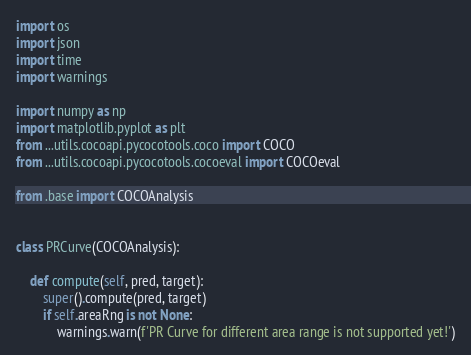Convert code to text. <code><loc_0><loc_0><loc_500><loc_500><_Python_>import os
import json
import time
import warnings

import numpy as np
import matplotlib.pyplot as plt
from ...utils.cocoapi.pycocotools.coco import COCO
from ...utils.cocoapi.pycocotools.cocoeval import COCOeval

from .base import COCOAnalysis


class PRCurve(COCOAnalysis):

    def compute(self, pred, target):
        super().compute(pred, target)
        if self.areaRng is not None:
            warnings.warn(f'PR Curve for different area range is not supported yet!')</code> 